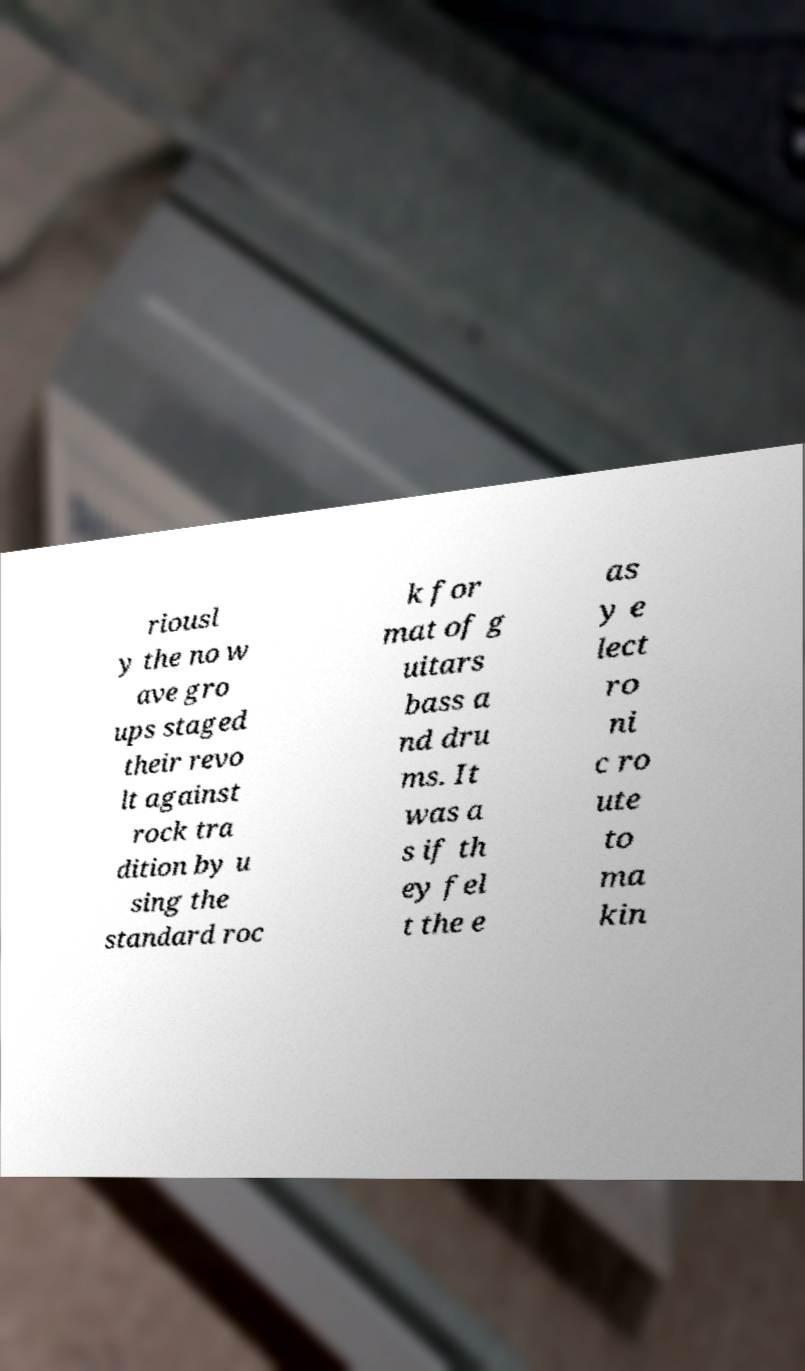I need the written content from this picture converted into text. Can you do that? riousl y the no w ave gro ups staged their revo lt against rock tra dition by u sing the standard roc k for mat of g uitars bass a nd dru ms. It was a s if th ey fel t the e as y e lect ro ni c ro ute to ma kin 